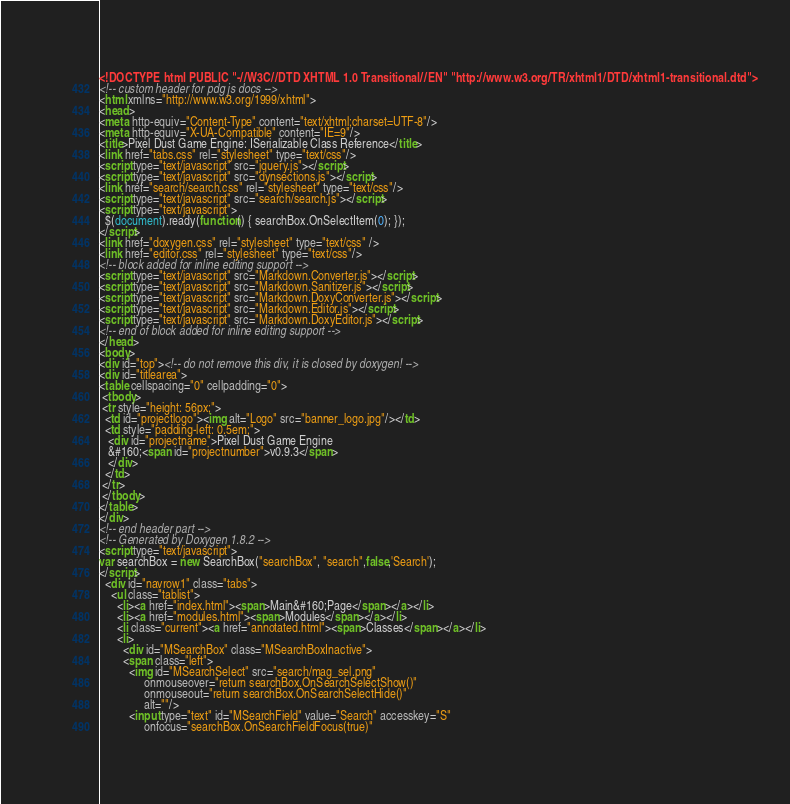<code> <loc_0><loc_0><loc_500><loc_500><_HTML_><!DOCTYPE html PUBLIC "-//W3C//DTD XHTML 1.0 Transitional//EN" "http://www.w3.org/TR/xhtml1/DTD/xhtml1-transitional.dtd">
<!-- custom header for pdg js docs -->
<html xmlns="http://www.w3.org/1999/xhtml">
<head>
<meta http-equiv="Content-Type" content="text/xhtml;charset=UTF-8"/>
<meta http-equiv="X-UA-Compatible" content="IE=9"/>
<title>Pixel Dust Game Engine: ISerializable Class Reference</title>
<link href="tabs.css" rel="stylesheet" type="text/css"/>
<script type="text/javascript" src="jquery.js"></script>
<script type="text/javascript" src="dynsections.js"></script>
<link href="search/search.css" rel="stylesheet" type="text/css"/>
<script type="text/javascript" src="search/search.js"></script>
<script type="text/javascript">
  $(document).ready(function() { searchBox.OnSelectItem(0); });
</script>
<link href="doxygen.css" rel="stylesheet" type="text/css" />
<link href="editor.css" rel="stylesheet" type="text/css"/>
<!-- block added for inline editing support -->
<script type="text/javascript" src="Markdown.Converter.js"></script>
<script type="text/javascript" src="Markdown.Sanitizer.js"></script>
<script type="text/javascript" src="Markdown.DoxyConverter.js"></script>
<script type="text/javascript" src="Markdown.Editor.js"></script>
<script type="text/javascript" src="Markdown.DoxyEditor.js"></script>
<!-- end of block added for inline editing support -->
</head>
<body>
<div id="top"><!-- do not remove this div, it is closed by doxygen! -->
<div id="titlearea">
<table cellspacing="0" cellpadding="0">
 <tbody>
 <tr style="height: 56px;">
  <td id="projectlogo"><img alt="Logo" src="banner_logo.jpg"/></td>
  <td style="padding-left: 0.5em;">
   <div id="projectname">Pixel Dust Game Engine
   &#160;<span id="projectnumber">v0.9.3</span>
   </div>
  </td>
 </tr>
 </tbody>
</table>
</div>
<!-- end header part -->
<!-- Generated by Doxygen 1.8.2 -->
<script type="text/javascript">
var searchBox = new SearchBox("searchBox", "search",false,'Search');
</script>
  <div id="navrow1" class="tabs">
    <ul class="tablist">
      <li><a href="index.html"><span>Main&#160;Page</span></a></li>
      <li><a href="modules.html"><span>Modules</span></a></li>
      <li class="current"><a href="annotated.html"><span>Classes</span></a></li>
      <li>
        <div id="MSearchBox" class="MSearchBoxInactive">
        <span class="left">
          <img id="MSearchSelect" src="search/mag_sel.png"
               onmouseover="return searchBox.OnSearchSelectShow()"
               onmouseout="return searchBox.OnSearchSelectHide()"
               alt=""/>
          <input type="text" id="MSearchField" value="Search" accesskey="S"
               onfocus="searchBox.OnSearchFieldFocus(true)" </code> 